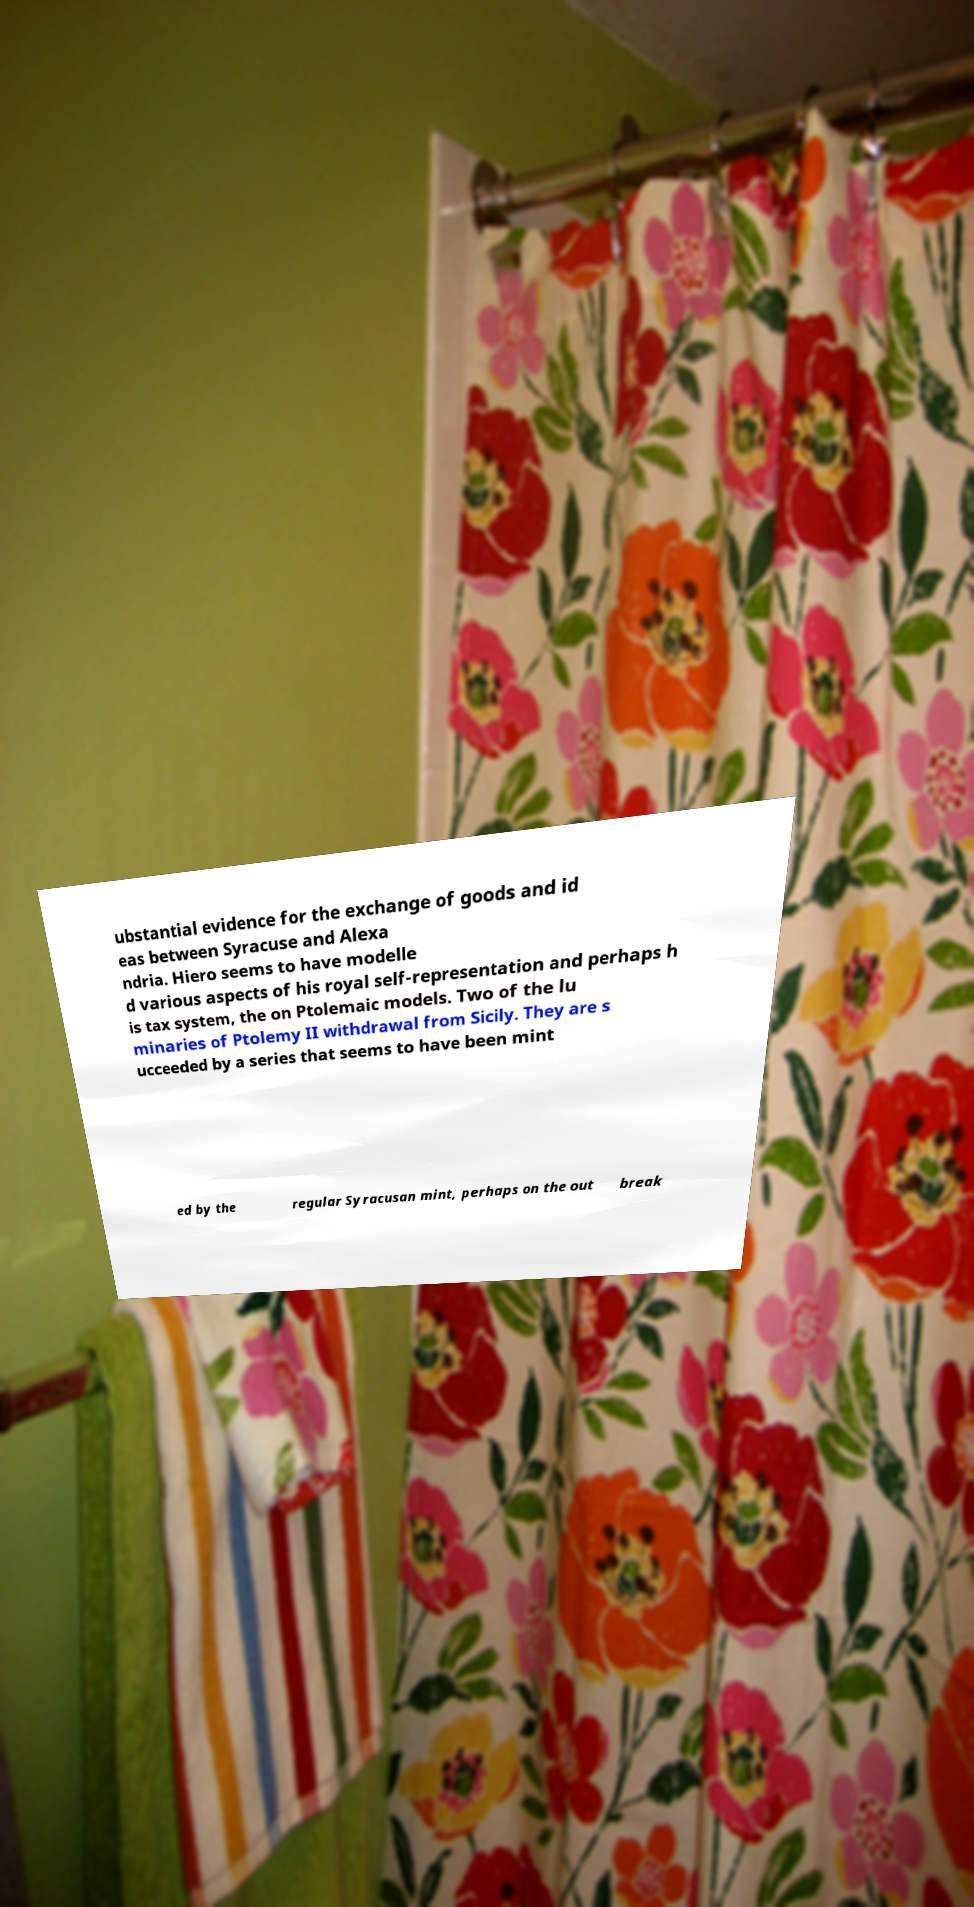For documentation purposes, I need the text within this image transcribed. Could you provide that? ubstantial evidence for the exchange of goods and id eas between Syracuse and Alexa ndria. Hiero seems to have modelle d various aspects of his royal self-representation and perhaps h is tax system, the on Ptolemaic models. Two of the lu minaries of Ptolemy II withdrawal from Sicily. They are s ucceeded by a series that seems to have been mint ed by the regular Syracusan mint, perhaps on the out break 